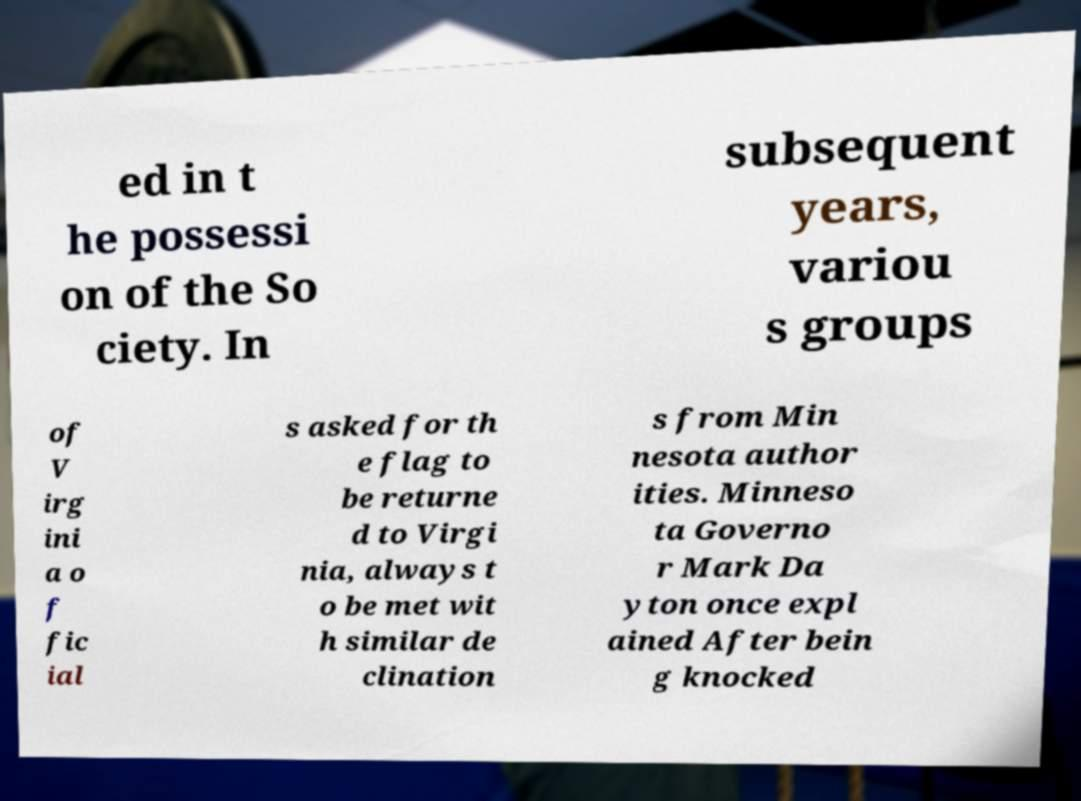Please read and relay the text visible in this image. What does it say? ed in t he possessi on of the So ciety. In subsequent years, variou s groups of V irg ini a o f fic ial s asked for th e flag to be returne d to Virgi nia, always t o be met wit h similar de clination s from Min nesota author ities. Minneso ta Governo r Mark Da yton once expl ained After bein g knocked 